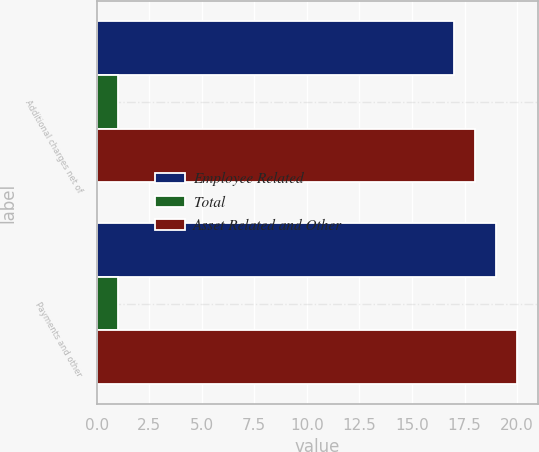Convert chart. <chart><loc_0><loc_0><loc_500><loc_500><stacked_bar_chart><ecel><fcel>Additional charges net of<fcel>Payments and other<nl><fcel>Employee Related<fcel>17<fcel>19<nl><fcel>Total<fcel>1<fcel>1<nl><fcel>Asset Related and Other<fcel>18<fcel>20<nl></chart> 